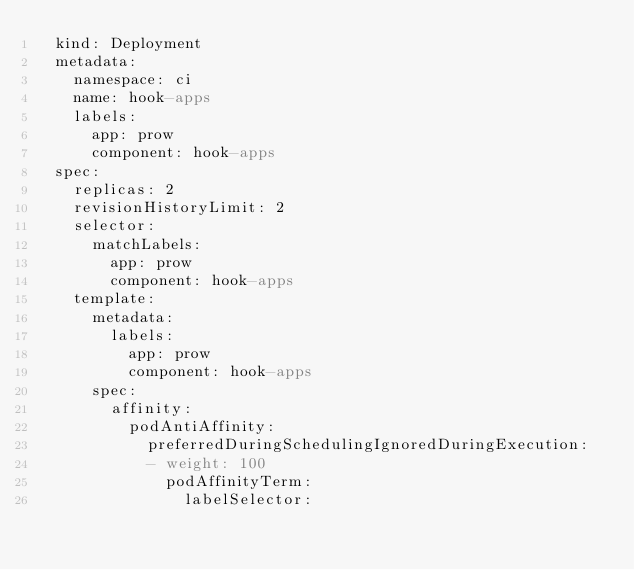Convert code to text. <code><loc_0><loc_0><loc_500><loc_500><_YAML_>  kind: Deployment
  metadata:
    namespace: ci
    name: hook-apps
    labels:
      app: prow
      component: hook-apps
  spec:
    replicas: 2
    revisionHistoryLimit: 2
    selector:
      matchLabels:
        app: prow
        component: hook-apps
    template:
      metadata:
        labels:
          app: prow
          component: hook-apps
      spec:
        affinity:
          podAntiAffinity:
            preferredDuringSchedulingIgnoredDuringExecution:
            - weight: 100
              podAffinityTerm:
                labelSelector:</code> 